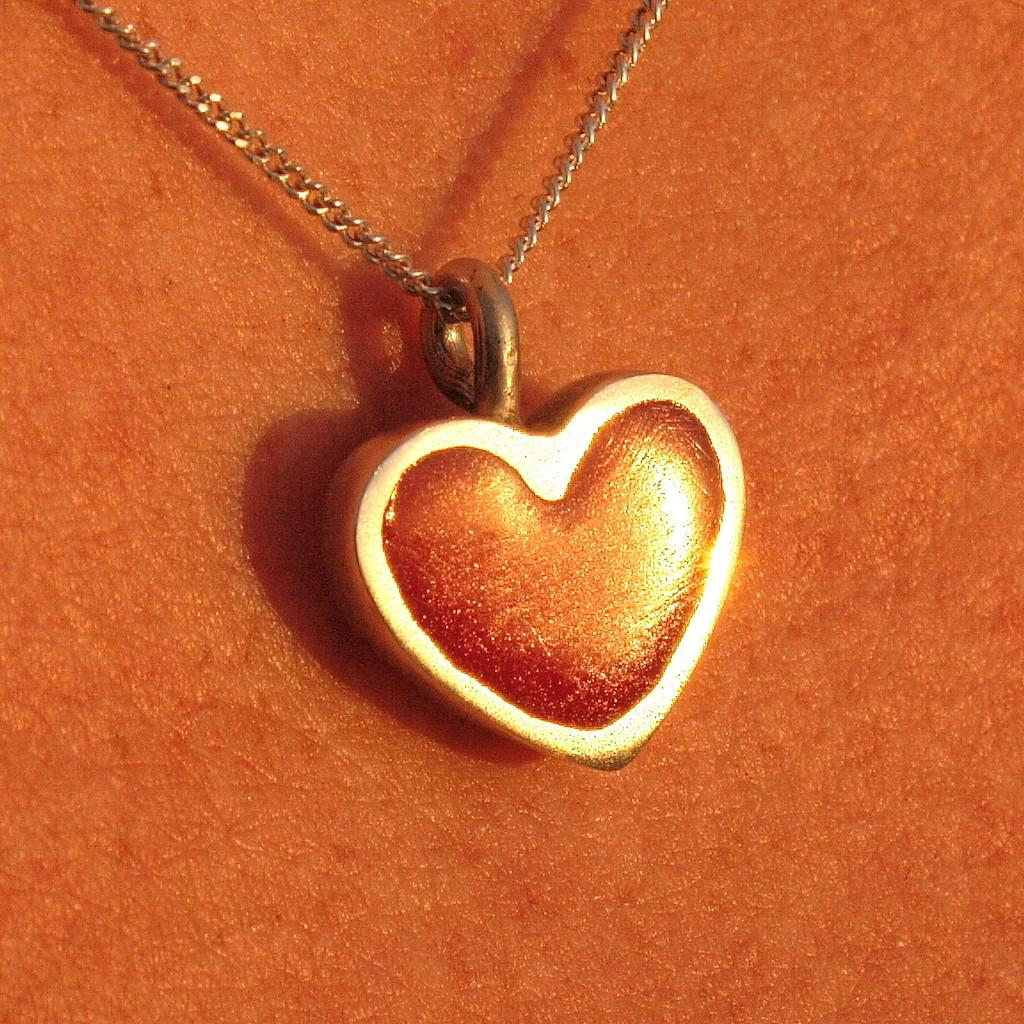What is the main object in the image? There is a chain in the image. Is there anything attached to the chain? Yes, there is a locket attached to the chain. How does the cushion help with digestion in the image? There is no cushion present in the image, and therefore no such activity can be observed. 